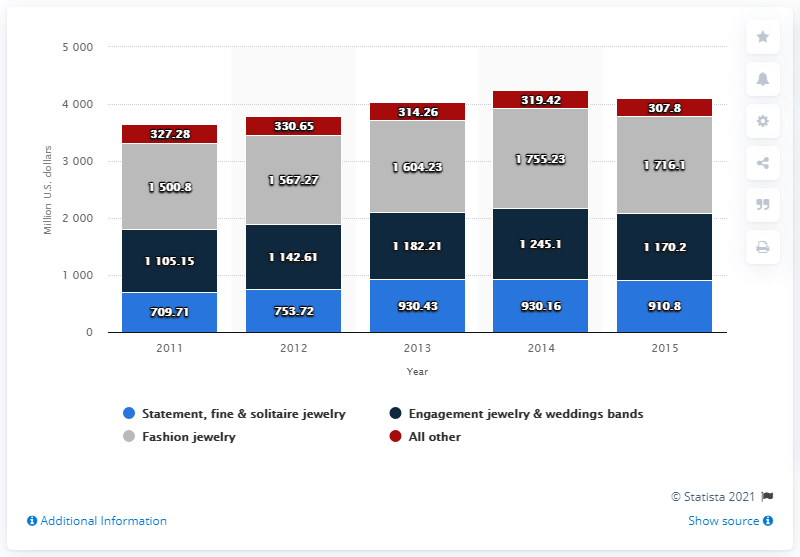Identify some key points in this picture. The difference between the 2011 blue bar value and the 2015 blue bar value is 201.1. In 2013, the net sales of Tiffany & Co.'s fashion jewelry segment were $1604.23. The blue bar has a highest value of 930.43... 